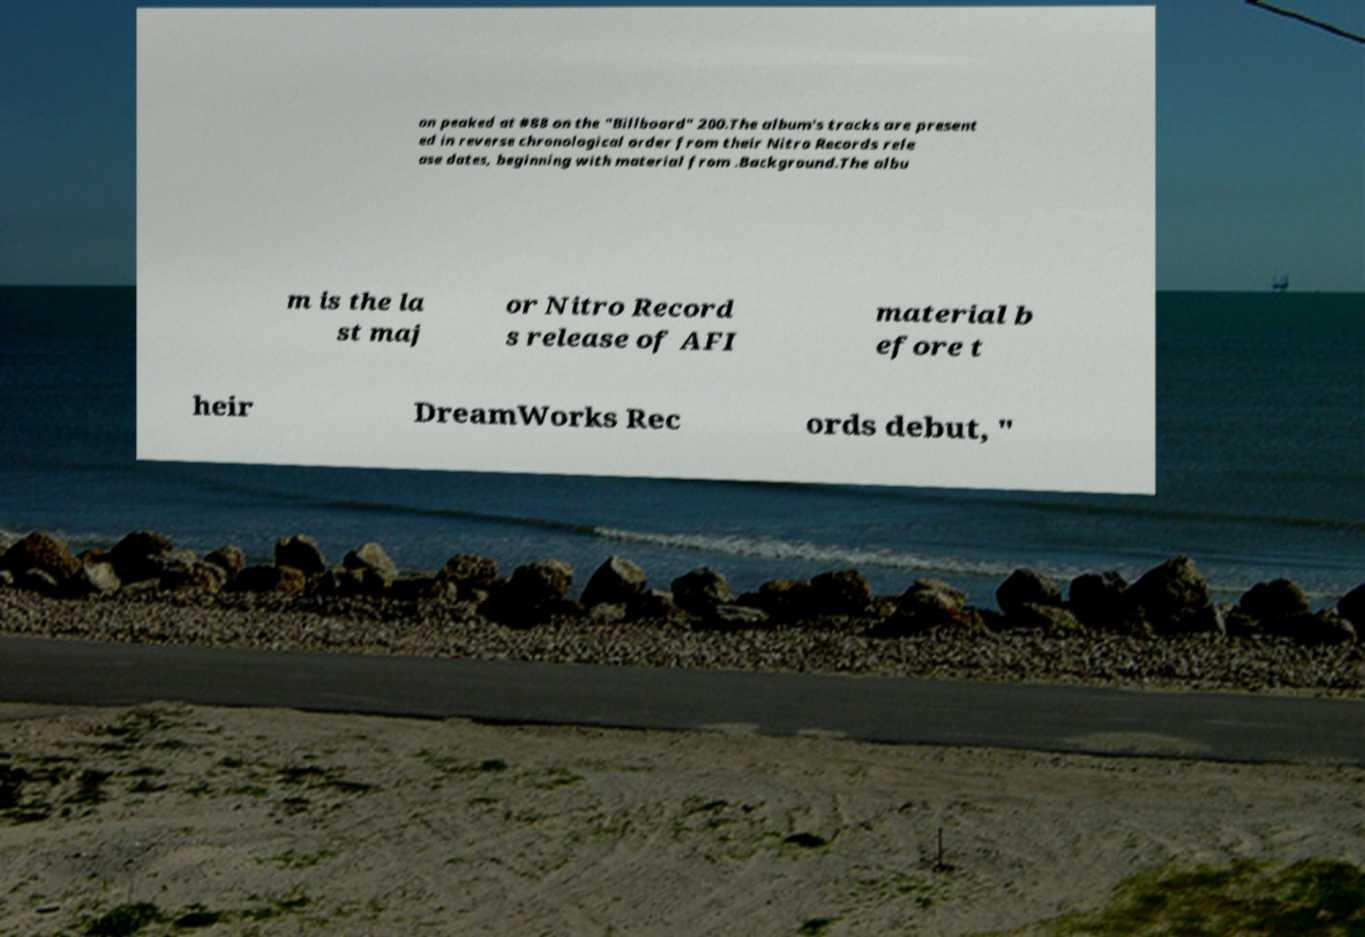Please read and relay the text visible in this image. What does it say? on peaked at #88 on the "Billboard" 200.The album's tracks are present ed in reverse chronological order from their Nitro Records rele ase dates, beginning with material from .Background.The albu m is the la st maj or Nitro Record s release of AFI material b efore t heir DreamWorks Rec ords debut, " 